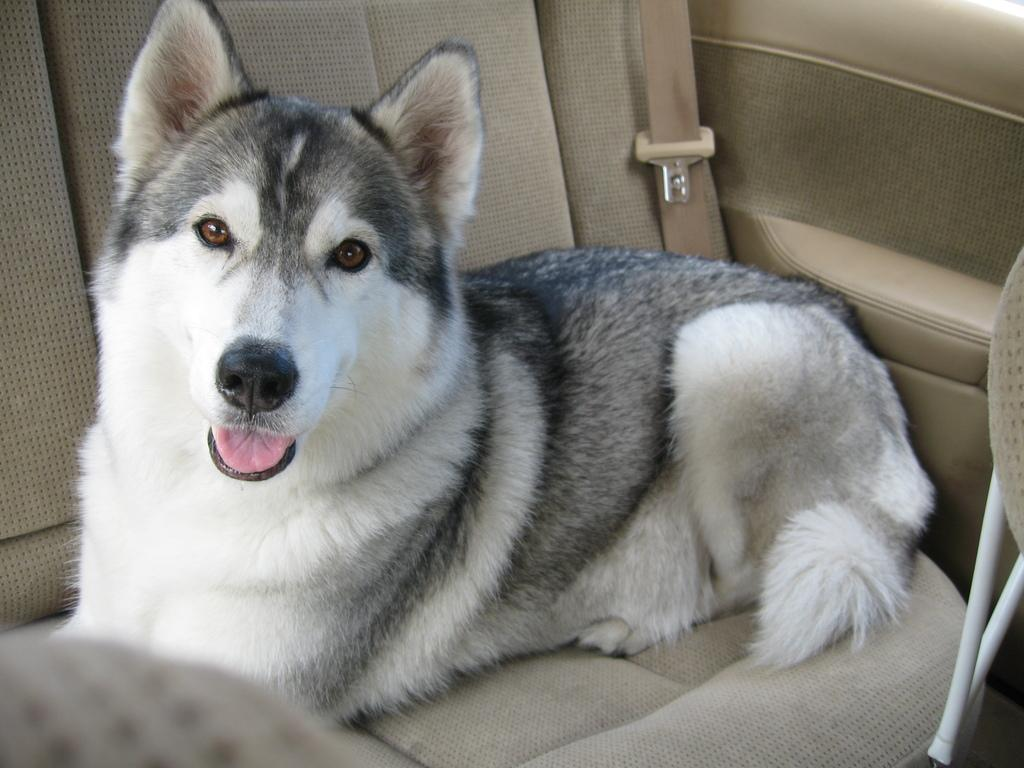What animal is present in the image? There is a dog in the image. Where is the dog located in the image? The dog is in the back seat of a vehicle. What colors can be seen on the dog in the image? The dog is white and black in color. What type of ornament is the dog playing with in the image? There is no ornament present in the image, and the dog is not shown playing with anything. 